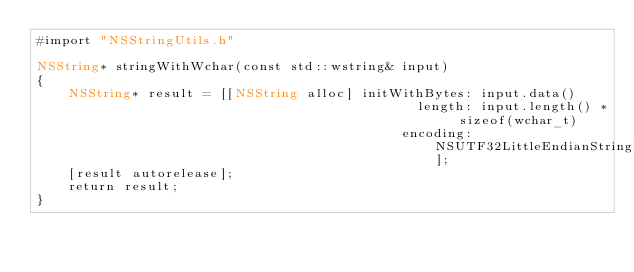<code> <loc_0><loc_0><loc_500><loc_500><_ObjectiveC_>#import "NSStringUtils.h"

NSString* stringWithWchar(const std::wstring& input)
{
	NSString* result = [[NSString alloc] initWithBytes: input.data()
												length: input.length() * sizeof(wchar_t)
											  encoding: NSUTF32LittleEndianStringEncoding];
	[result autorelease];
	return result;
}
</code> 